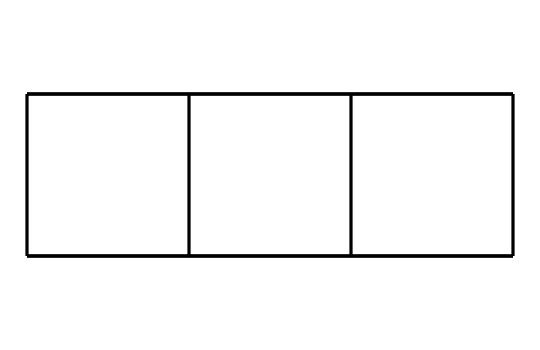What is the molecular formula of cubane? Cubane consists of 8 carbon atoms (C) and 10 hydrogen atoms (H). Therefore, the molecular formula can be derived by counting the number of each type of atom in the structure.
Answer: C8H10 How many valence electrons does each carbon atom contribute to cubane? Each carbon atom has 4 valence electrons, which can participate in forming bonds. In the case of cubane, all carbon atoms are fully utilized in bonding, thus yielding its structure.
Answer: 4 Is cubane a saturated or unsaturated compound? Cubane is a fully saturated compound, as all carbon atoms are bonded to the maximum number of hydrogens, with only single bonds between carbon atoms.
Answer: saturated What type of hybridization do the carbon atoms in cubane exhibit? The carbon atoms in cubane undergo sp3 hybridization due to their tetrahedral geometry from single bonds with hydrogen and other carbon atoms.
Answer: sp3 What is the symmetry point group of cubane? To determine the symmetry, we analyze the molecular geometry of cubane, which is highly symmetrical, revealing that it falls under the symmetry point group of Td.
Answer: Td How does cubane compare to conventional hydrocarbon fuels in terms of energy density? Cubane has a higher energy density compared to many conventional hydrocarbons due to its compact and high-energy cage-like structure that releases significant energy upon combustion.
Answer: higher energy density 